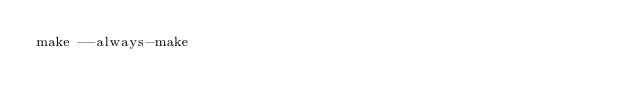<code> <loc_0><loc_0><loc_500><loc_500><_Bash_>make --always-make
</code> 